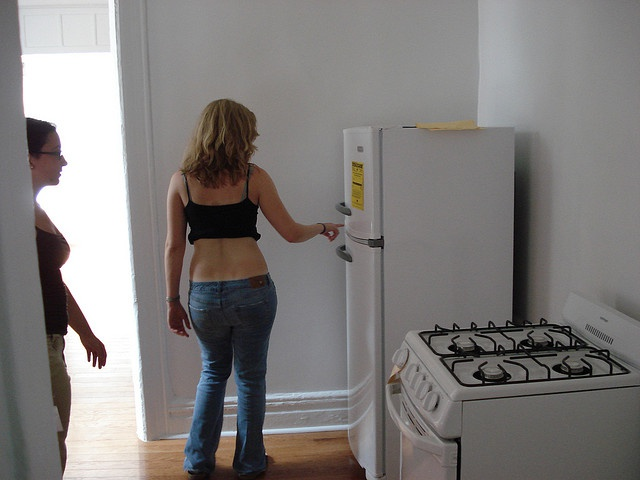Describe the objects in this image and their specific colors. I can see refrigerator in gray tones, oven in gray and black tones, people in gray, black, and maroon tones, and people in gray, black, maroon, white, and brown tones in this image. 